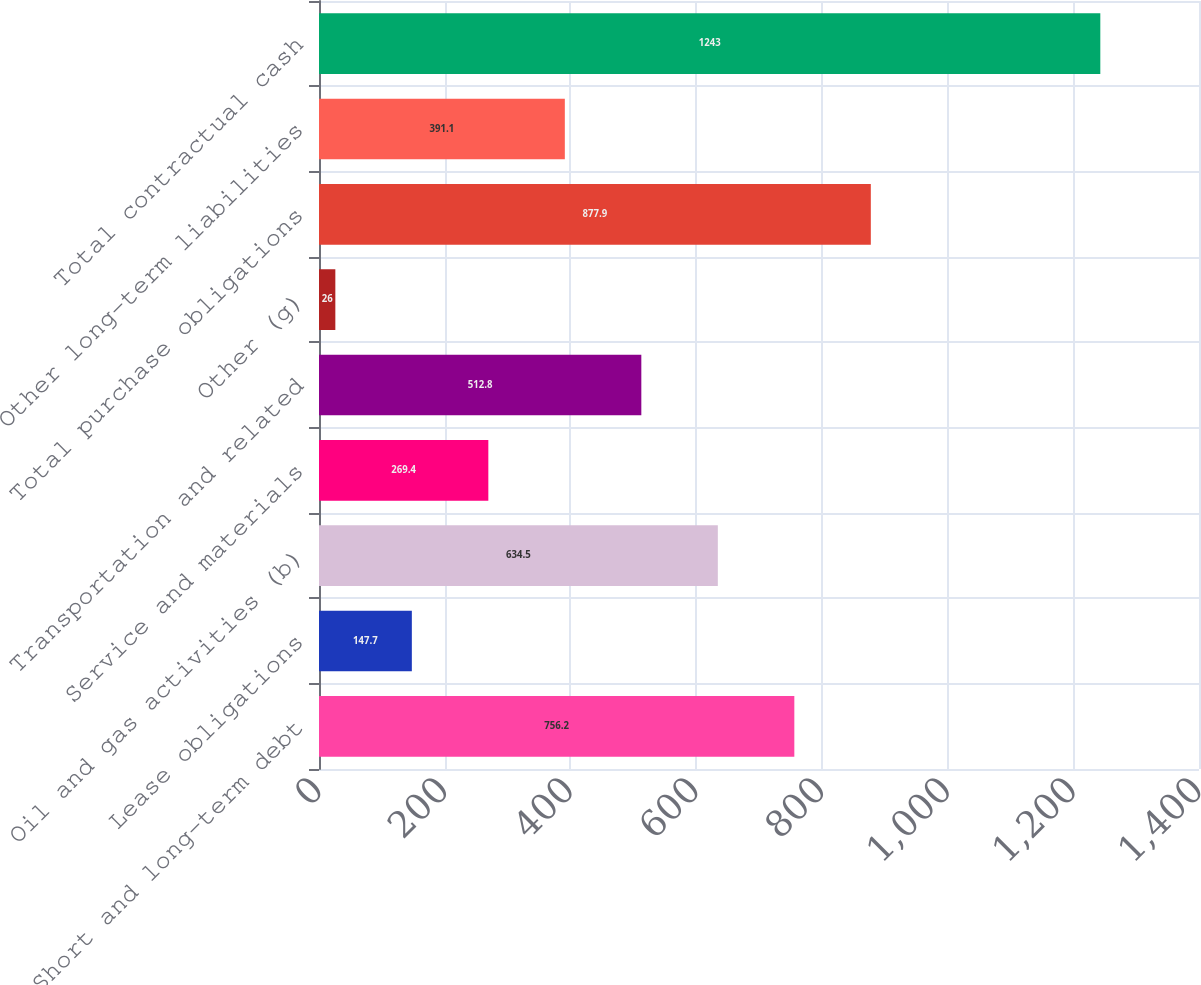Convert chart to OTSL. <chart><loc_0><loc_0><loc_500><loc_500><bar_chart><fcel>Short and long-term debt<fcel>Lease obligations<fcel>Oil and gas activities (b)<fcel>Service and materials<fcel>Transportation and related<fcel>Other (g)<fcel>Total purchase obligations<fcel>Other long-term liabilities<fcel>Total contractual cash<nl><fcel>756.2<fcel>147.7<fcel>634.5<fcel>269.4<fcel>512.8<fcel>26<fcel>877.9<fcel>391.1<fcel>1243<nl></chart> 